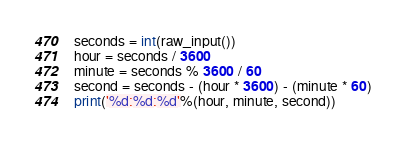<code> <loc_0><loc_0><loc_500><loc_500><_Python_>seconds = int(raw_input())
hour = seconds / 3600
minute = seconds % 3600 / 60
second = seconds - (hour * 3600) - (minute * 60)
print('%d:%d:%d'%(hour, minute, second))</code> 